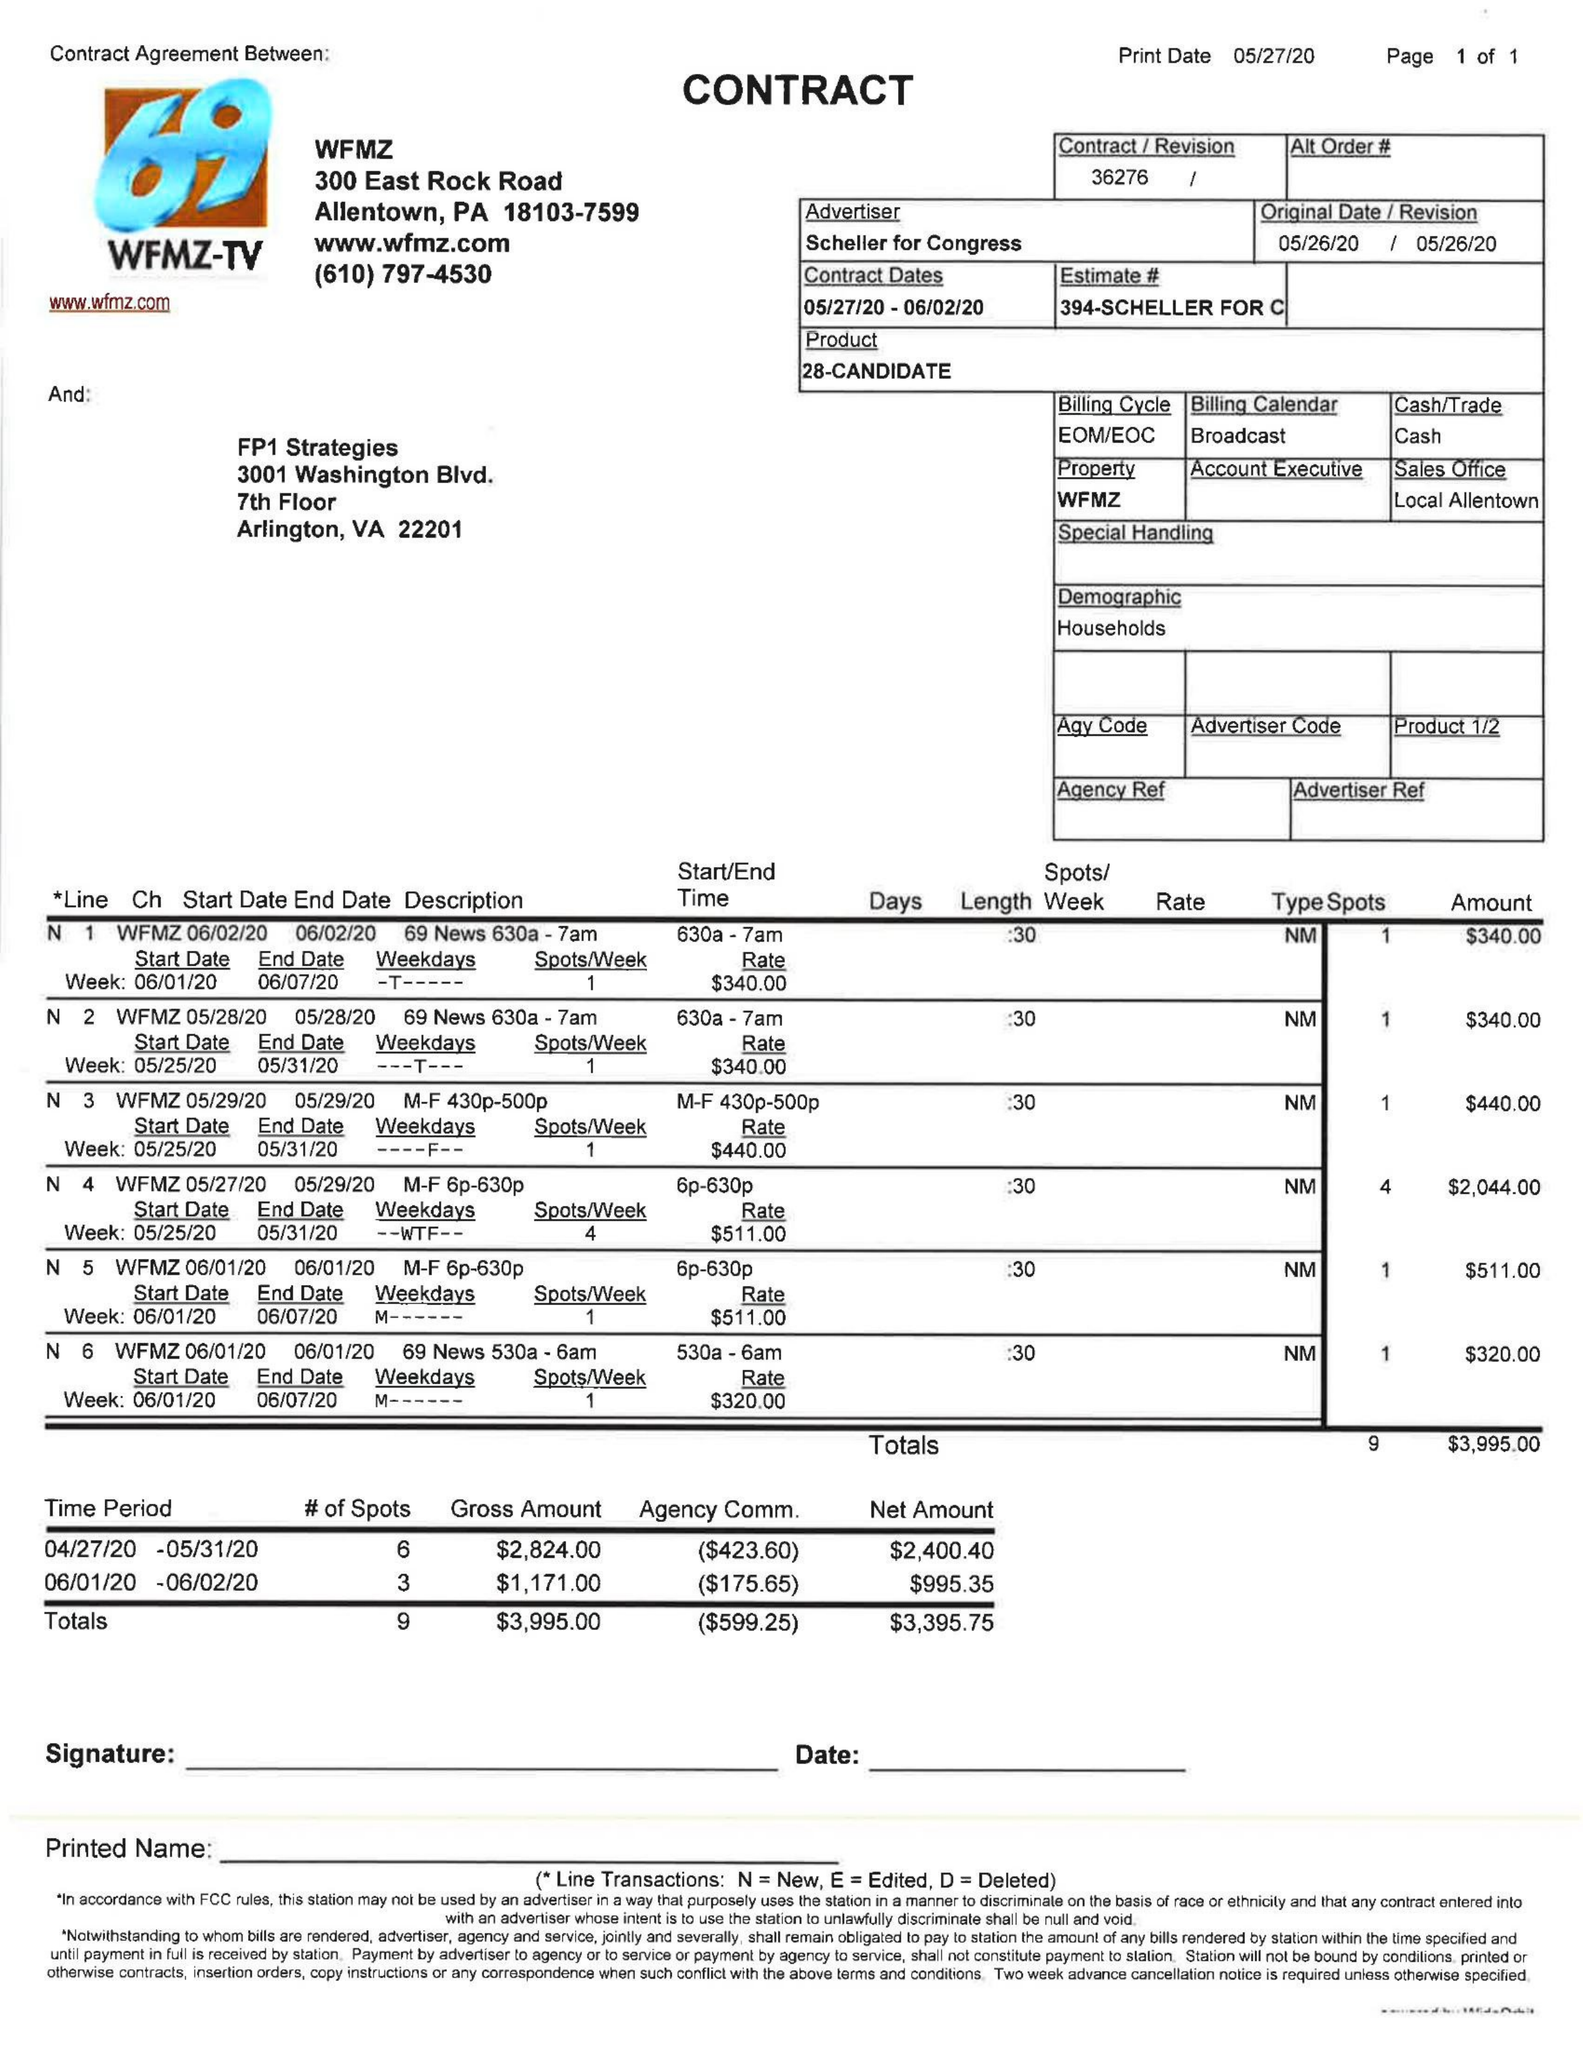What is the value for the advertiser?
Answer the question using a single word or phrase. SCHELLER FOR CONGRESS 